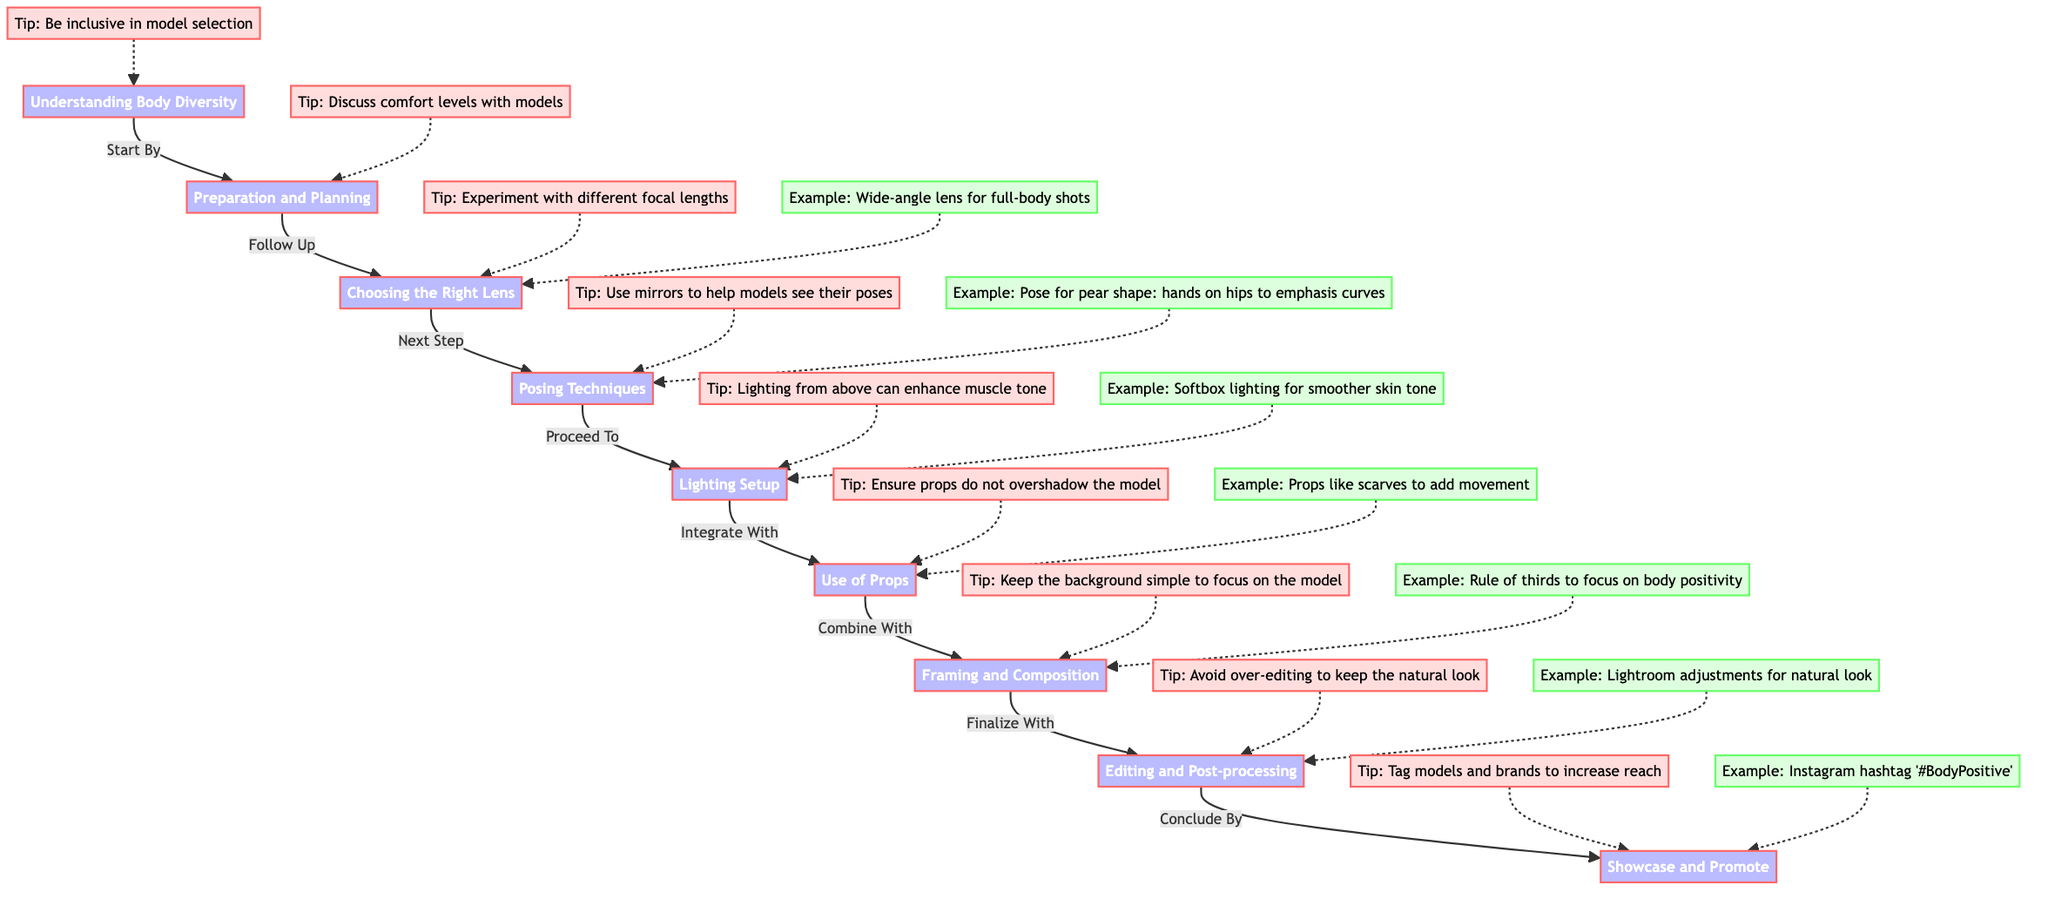What is the first step in the photographic guide? The diagram lists "Understanding Body Diversity" as the first step, indicating that comprehension of body diversity is foundational before proceeding with photography techniques.
Answer: Understanding Body Diversity What node follows "Preparation and Planning"? After "Preparation and Planning," the next node is "Choosing the Right Lens," showing the sequence of steps in the photographic process.
Answer: Choosing the Right Lens How many tips are provided for lighting setup? The diagram includes one tip associated with "Lighting Setup" which is "Lighting from above can enhance muscle tone," indicating that there is one piece of advice specifically for this node.
Answer: 1 What is an example given for "Posing Techniques"? An example given for "Posing Techniques" is "Pose for pear shape: hands on hips to emphasise curves," illustrating a specific approach to posing for a particular body type.
Answer: Pose for pear shape: hands on hips to emphasise curves Which node is preceded by "Framing and Composition"? "Editing and Post-processing" is the node that follows "Framing and Composition," indicating the ongoing progression in the photographic workflow.
Answer: Editing and Post-processing Describe the tip related to prop usage. The tip concerning props states, "Ensure props do not overshadow the model," which emphasizes that props should complement rather than detract from the main subject, the model.
Answer: Ensure props do not overshadow the model What two aspects should be kept simple according to the tips? The diagram suggests keeping the background simple and ensures props do not overshadow the model; both aspects are critical to focusing viewer attention on the model.
Answer: Background and props What is the purpose of tagging models and brands in the final step? Tagging models and brands is advised to increase reach, highlighting the importance of social media interactions in promoting the photographic work.
Answer: Increase reach What is an example provided for editing and post-processing? An example cited for "Editing and Post-processing" is "Lightroom adjustments for natural look," illustrating a method of maintaining the model's authenticity during editing.
Answer: Lightroom adjustments for natural look 